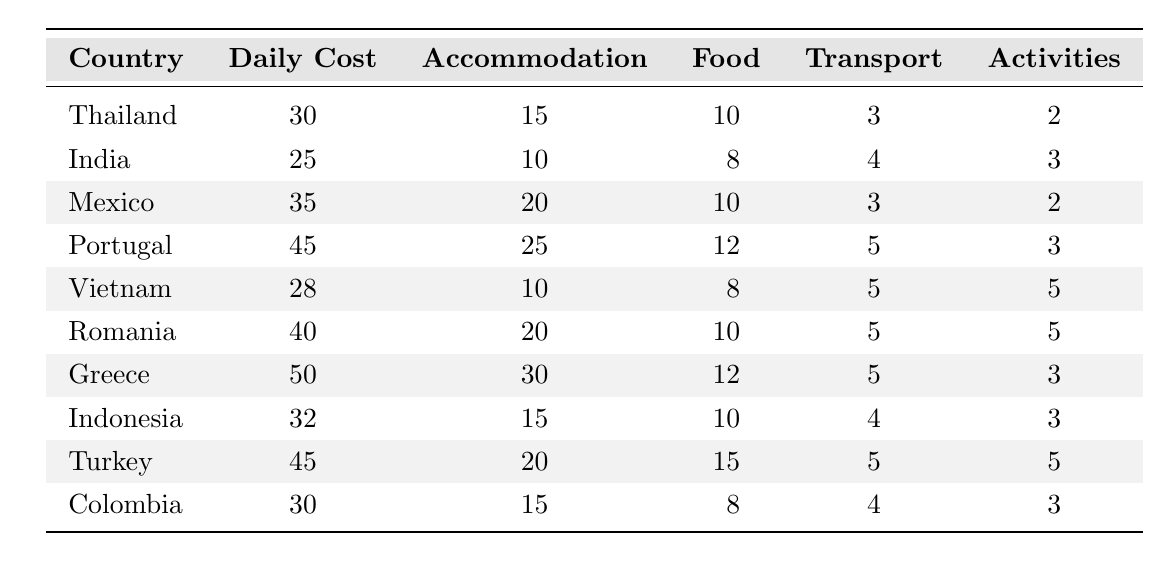What is the daily travel cost in Thailand? According to the table, the daily cost of travel in Thailand is listed directly under the "Daily Cost" column. It shows a value of 30.
Answer: 30 Which country has the lowest daily travel cost? To find the lowest daily travel cost, we need to compare the values in the "Daily Cost" column. The lowest value found in the table is 25, which corresponds to India.
Answer: India How much does accommodation cost in Greece? The table shows that the accommodation cost in Greece is listed under the "Accommodation" column. This value is 30.
Answer: 30 What is the total cost of food for a day in Vietnam? The table lists the food cost in Vietnam under the "Food" column, showing a value of 8. This is the daily cost of food while traveling.
Answer: 8 Which country has a daily cost of 45? By scanning the "Daily Cost" column for the value of 45, we can see that both Portugal and Turkey have this daily cost.
Answer: Portugal and Turkey What is the average accommodation cost of the countries listed? We add the accommodation costs together: 15 + 10 + 20 + 25 + 10 + 20 + 30 + 15 + 20 + 15 =  180. There are 10 countries, so we divide 180 by 10 to get an average of 18.
Answer: 18 Is the daily travel cost in Mexico higher than in Colombia? The daily costs listed for Mexico and Colombia are 35 and 30 respectively. Since 35 is greater than 30, the statement is true.
Answer: Yes What is the difference in daily travel cost between Greece and India? The daily cost for Greece is 50 and for India is 25. We subtract the two values: 50 - 25 = 25.
Answer: 25 Which country has the highest cost for activities? Looking at the "Activities" column, we see the highest cost listed is 5, which is found in Vietnam, Romania, Turkey, and Indonesia.
Answer: Vietnam, Romania, Turkey, Indonesia Calculate the total daily travel cost for Portugal, including accommodation, food, transport, and activities. We add the costs together for Portugal: 25 (Accommodation) + 12 (Food) + 5 (Transport) + 3 (Activities) = 45. Since the daily cost is also 45, it confirms the table's total.
Answer: 45 